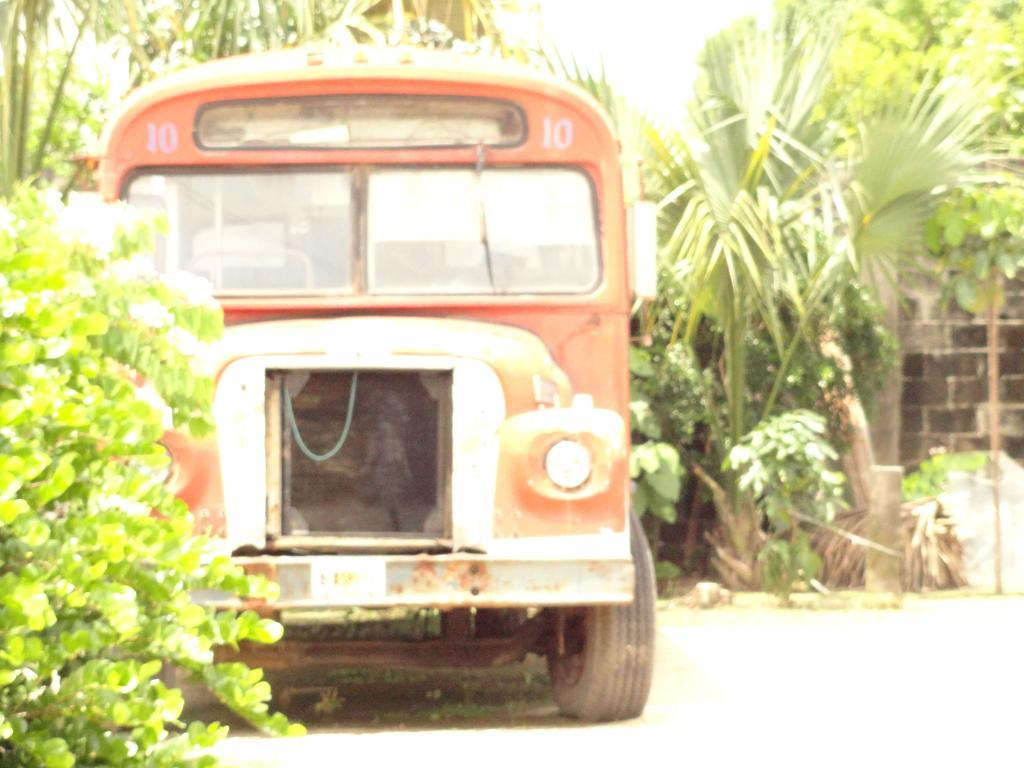What is the main subject of the image? There is a bus in the image. Where is the bus located? The bus is on the road. What type of vegetation can be seen in the image? There are plants and trees visible in the image. Can you tell me how many pigs are running alongside the bus in the image? There are no pigs present in the image; it only features a bus on the road and vegetation in the background. Is there a spy visible in the image? There is no indication of a spy in the image; it only shows a bus on the road and vegetation in the background. 